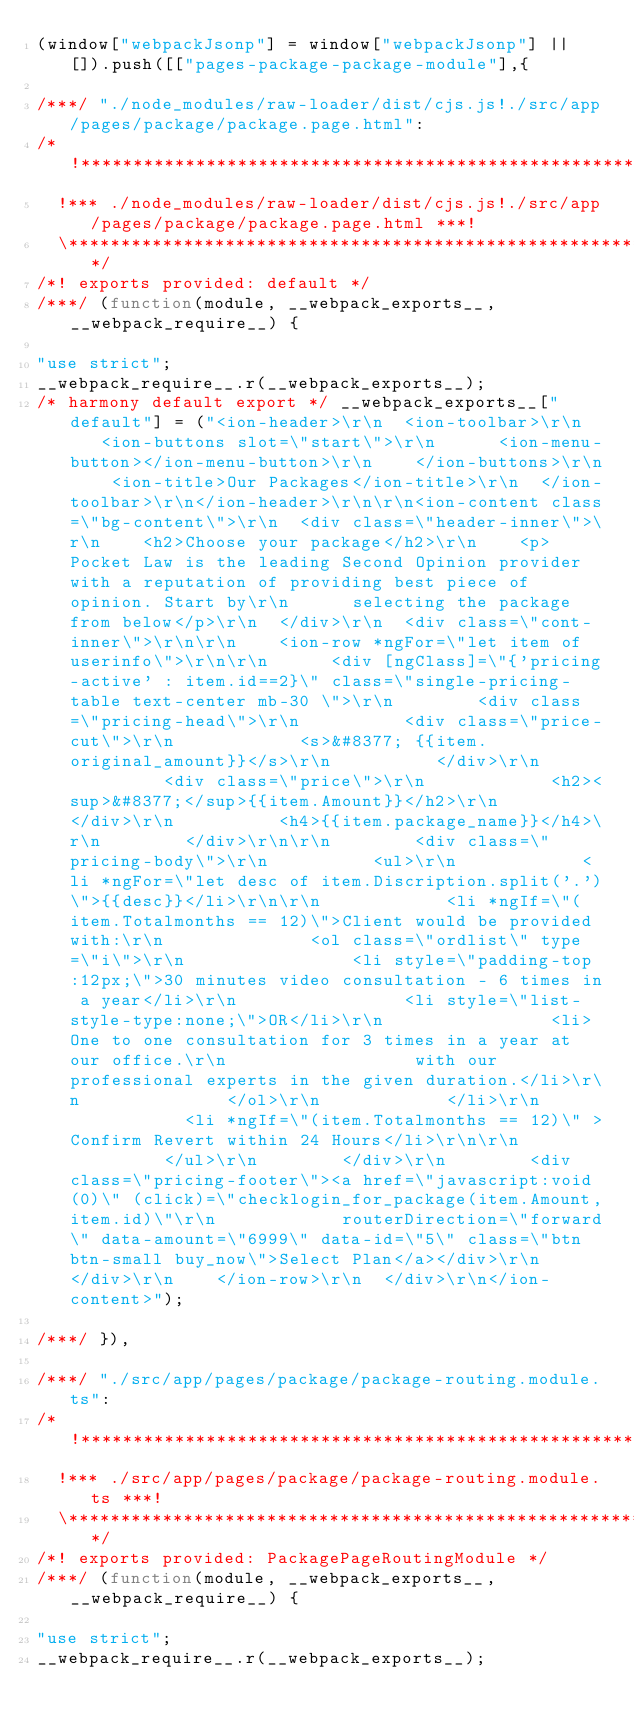Convert code to text. <code><loc_0><loc_0><loc_500><loc_500><_JavaScript_>(window["webpackJsonp"] = window["webpackJsonp"] || []).push([["pages-package-package-module"],{

/***/ "./node_modules/raw-loader/dist/cjs.js!./src/app/pages/package/package.page.html":
/*!***************************************************************************************!*\
  !*** ./node_modules/raw-loader/dist/cjs.js!./src/app/pages/package/package.page.html ***!
  \***************************************************************************************/
/*! exports provided: default */
/***/ (function(module, __webpack_exports__, __webpack_require__) {

"use strict";
__webpack_require__.r(__webpack_exports__);
/* harmony default export */ __webpack_exports__["default"] = ("<ion-header>\r\n  <ion-toolbar>\r\n    <ion-buttons slot=\"start\">\r\n      <ion-menu-button></ion-menu-button>\r\n    </ion-buttons>\r\n    <ion-title>Our Packages</ion-title>\r\n  </ion-toolbar>\r\n</ion-header>\r\n\r\n<ion-content class=\"bg-content\">\r\n  <div class=\"header-inner\">\r\n    <h2>Choose your package</h2>\r\n    <p>Pocket Law is the leading Second Opinion provider with a reputation of providing best piece of opinion. Start by\r\n      selecting the package from below</p>\r\n  </div>\r\n  <div class=\"cont-inner\">\r\n\r\n    <ion-row *ngFor=\"let item of userinfo\">\r\n\r\n      <div [ngClass]=\"{'pricing-active' : item.id==2}\" class=\"single-pricing-table text-center mb-30 \">\r\n        <div class=\"pricing-head\">\r\n          <div class=\"price-cut\">\r\n            <s>&#8377; {{item.original_amount}}</s>\r\n          </div>\r\n          <div class=\"price\">\r\n            <h2><sup>&#8377;</sup>{{item.Amount}}</h2>\r\n          </div>\r\n          <h4>{{item.package_name}}</h4>\r\n        </div>\r\n\r\n        <div class=\"pricing-body\">\r\n          <ul>\r\n            <li *ngFor=\"let desc of item.Discription.split('.')\">{{desc}}</li>\r\n\r\n            <li *ngIf=\"(item.Totalmonths == 12)\">Client would be provided with:\r\n              <ol class=\"ordlist\" type=\"i\">\r\n                <li style=\"padding-top:12px;\">30 minutes video consultation - 6 times in a year</li>\r\n                <li style=\"list-style-type:none;\">OR</li>\r\n                <li>One to one consultation for 3 times in a year at our office.\r\n                  with our professional experts in the given duration.</li>\r\n              </ol>\r\n            </li>\r\n            <li *ngIf=\"(item.Totalmonths == 12)\" >Confirm Revert within 24 Hours</li>\r\n\r\n          </ul>\r\n        </div>\r\n        <div class=\"pricing-footer\"><a href=\"javascript:void(0)\" (click)=\"checklogin_for_package(item.Amount,item.id)\"\r\n            routerDirection=\"forward\" data-amount=\"6999\" data-id=\"5\" class=\"btn btn-small buy_now\">Select Plan</a></div>\r\n      </div>\r\n    </ion-row>\r\n  </div>\r\n</ion-content>");

/***/ }),

/***/ "./src/app/pages/package/package-routing.module.ts":
/*!*********************************************************!*\
  !*** ./src/app/pages/package/package-routing.module.ts ***!
  \*********************************************************/
/*! exports provided: PackagePageRoutingModule */
/***/ (function(module, __webpack_exports__, __webpack_require__) {

"use strict";
__webpack_require__.r(__webpack_exports__);</code> 